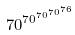<formula> <loc_0><loc_0><loc_500><loc_500>7 0 ^ { 7 0 ^ { 7 0 ^ { 7 0 ^ { 7 6 } } } }</formula> 